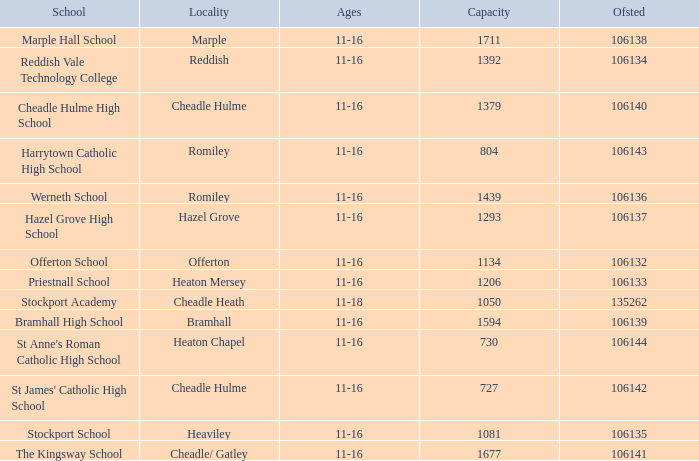Which School has a Capacity larger than 730, and an Ofsted smaller than 106135, and a Locality of heaton mersey? Priestnall School. 